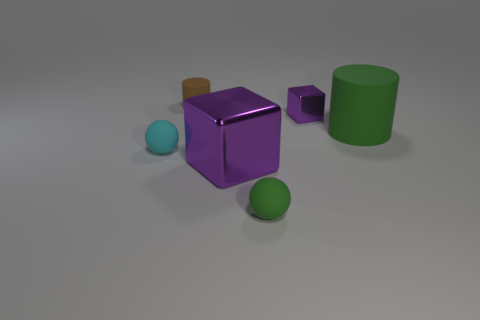Add 2 green rubber balls. How many objects exist? 8 Subtract all balls. How many objects are left? 4 Add 6 tiny green metallic blocks. How many tiny green metallic blocks exist? 6 Subtract 0 gray cubes. How many objects are left? 6 Subtract all yellow cylinders. Subtract all purple cubes. How many cylinders are left? 2 Subtract all tiny brown matte cylinders. Subtract all big green matte things. How many objects are left? 4 Add 3 small brown rubber cylinders. How many small brown rubber cylinders are left? 4 